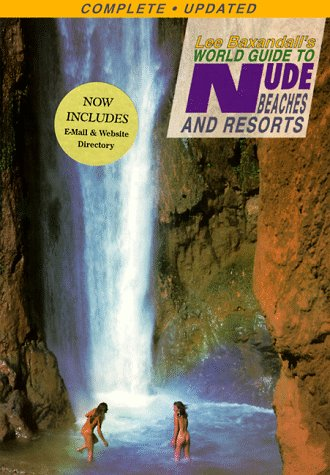Is this book related to Travel? Yes, the book is directly related to the travel genre with a specific focus on naturist-friendly destinations worldwide. 